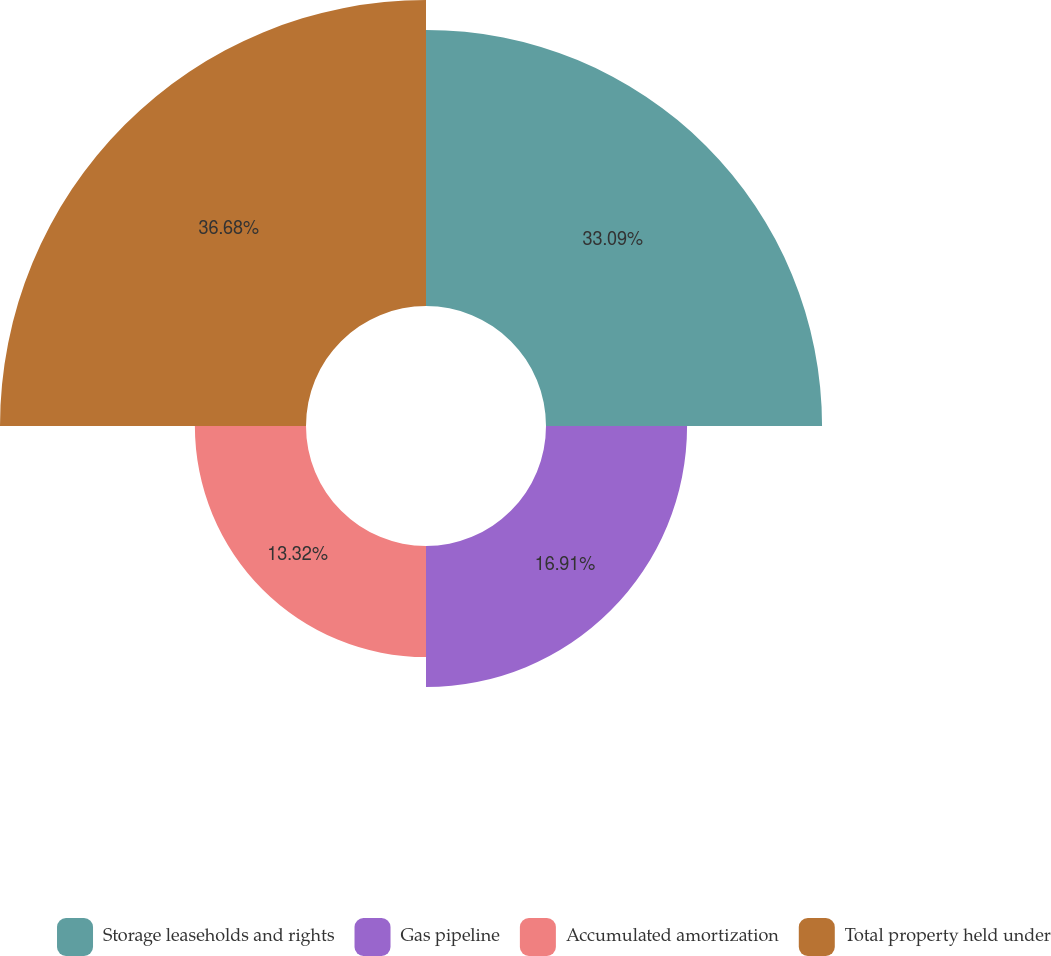Convert chart. <chart><loc_0><loc_0><loc_500><loc_500><pie_chart><fcel>Storage leaseholds and rights<fcel>Gas pipeline<fcel>Accumulated amortization<fcel>Total property held under<nl><fcel>33.09%<fcel>16.91%<fcel>13.32%<fcel>36.68%<nl></chart> 